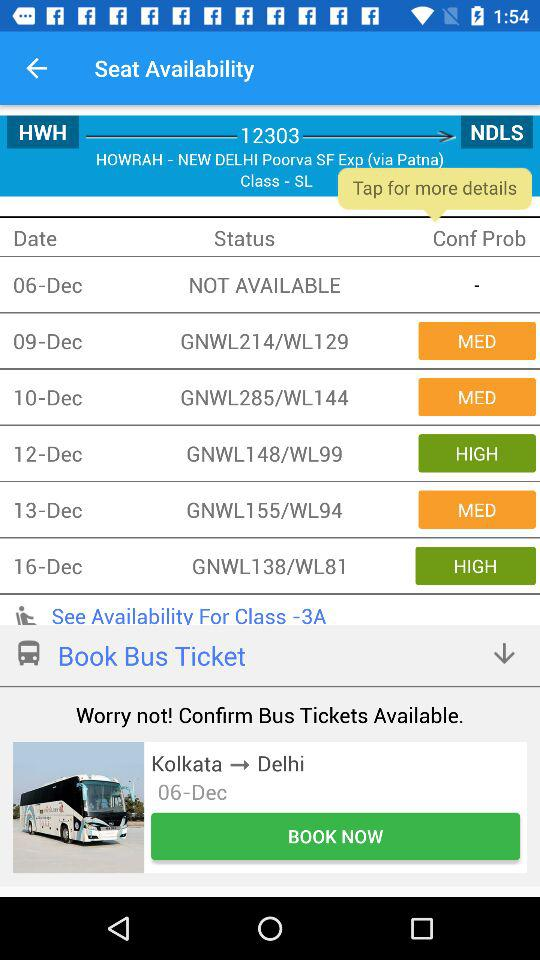What is the train number from Howrah to New Delhi? The train number is 12303. 